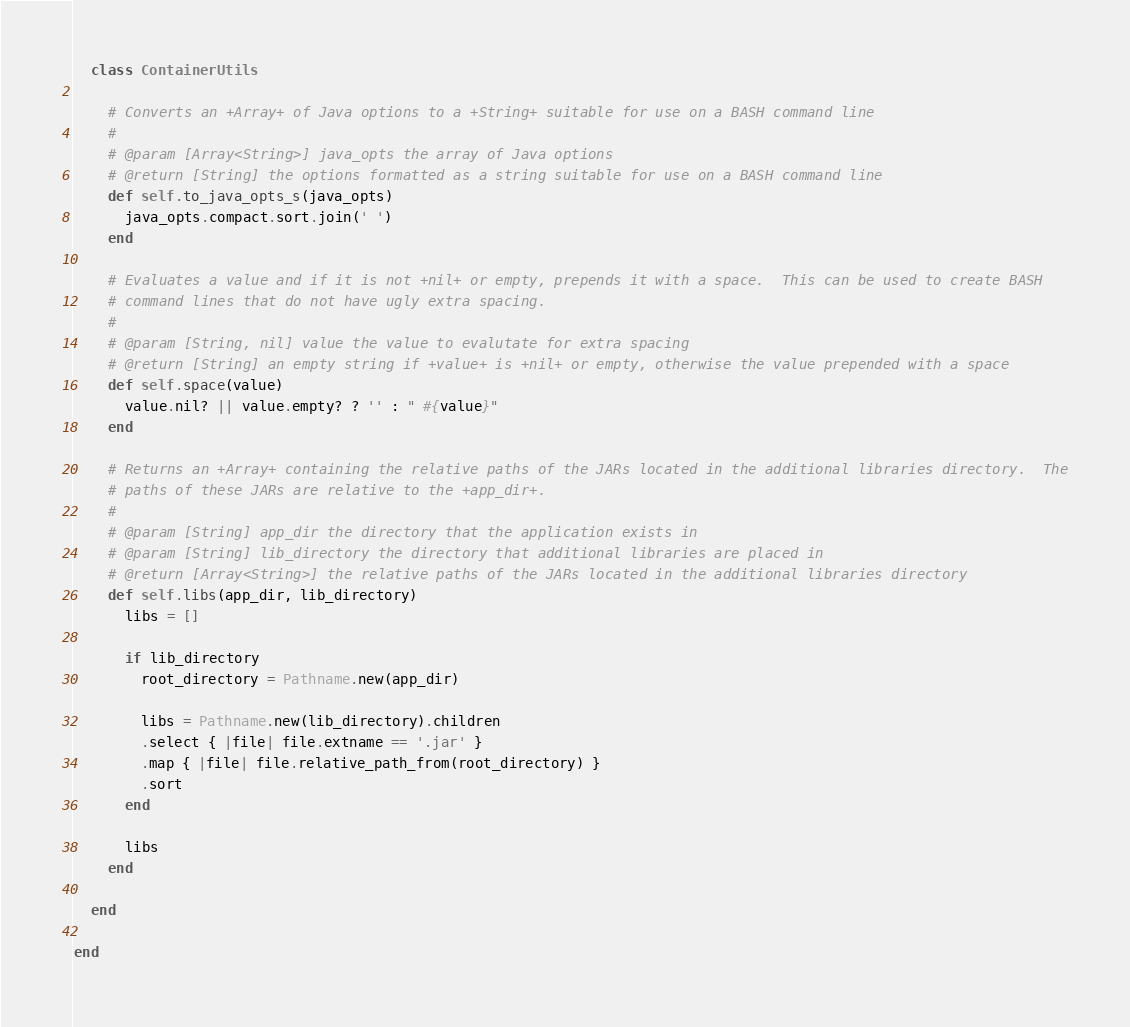<code> <loc_0><loc_0><loc_500><loc_500><_Ruby_>  class ContainerUtils

    # Converts an +Array+ of Java options to a +String+ suitable for use on a BASH command line
    #
    # @param [Array<String>] java_opts the array of Java options
    # @return [String] the options formatted as a string suitable for use on a BASH command line
    def self.to_java_opts_s(java_opts)
      java_opts.compact.sort.join(' ')
    end

    # Evaluates a value and if it is not +nil+ or empty, prepends it with a space.  This can be used to create BASH
    # command lines that do not have ugly extra spacing.
    #
    # @param [String, nil] value the value to evalutate for extra spacing
    # @return [String] an empty string if +value+ is +nil+ or empty, otherwise the value prepended with a space
    def self.space(value)
      value.nil? || value.empty? ? '' : " #{value}"
    end

    # Returns an +Array+ containing the relative paths of the JARs located in the additional libraries directory.  The
    # paths of these JARs are relative to the +app_dir+.
    #
    # @param [String] app_dir the directory that the application exists in
    # @param [String] lib_directory the directory that additional libraries are placed in
    # @return [Array<String>] the relative paths of the JARs located in the additional libraries directory
    def self.libs(app_dir, lib_directory)
      libs = []

      if lib_directory
        root_directory = Pathname.new(app_dir)

        libs = Pathname.new(lib_directory).children
        .select { |file| file.extname == '.jar' }
        .map { |file| file.relative_path_from(root_directory) }
        .sort
      end

      libs
    end

  end

end</code> 